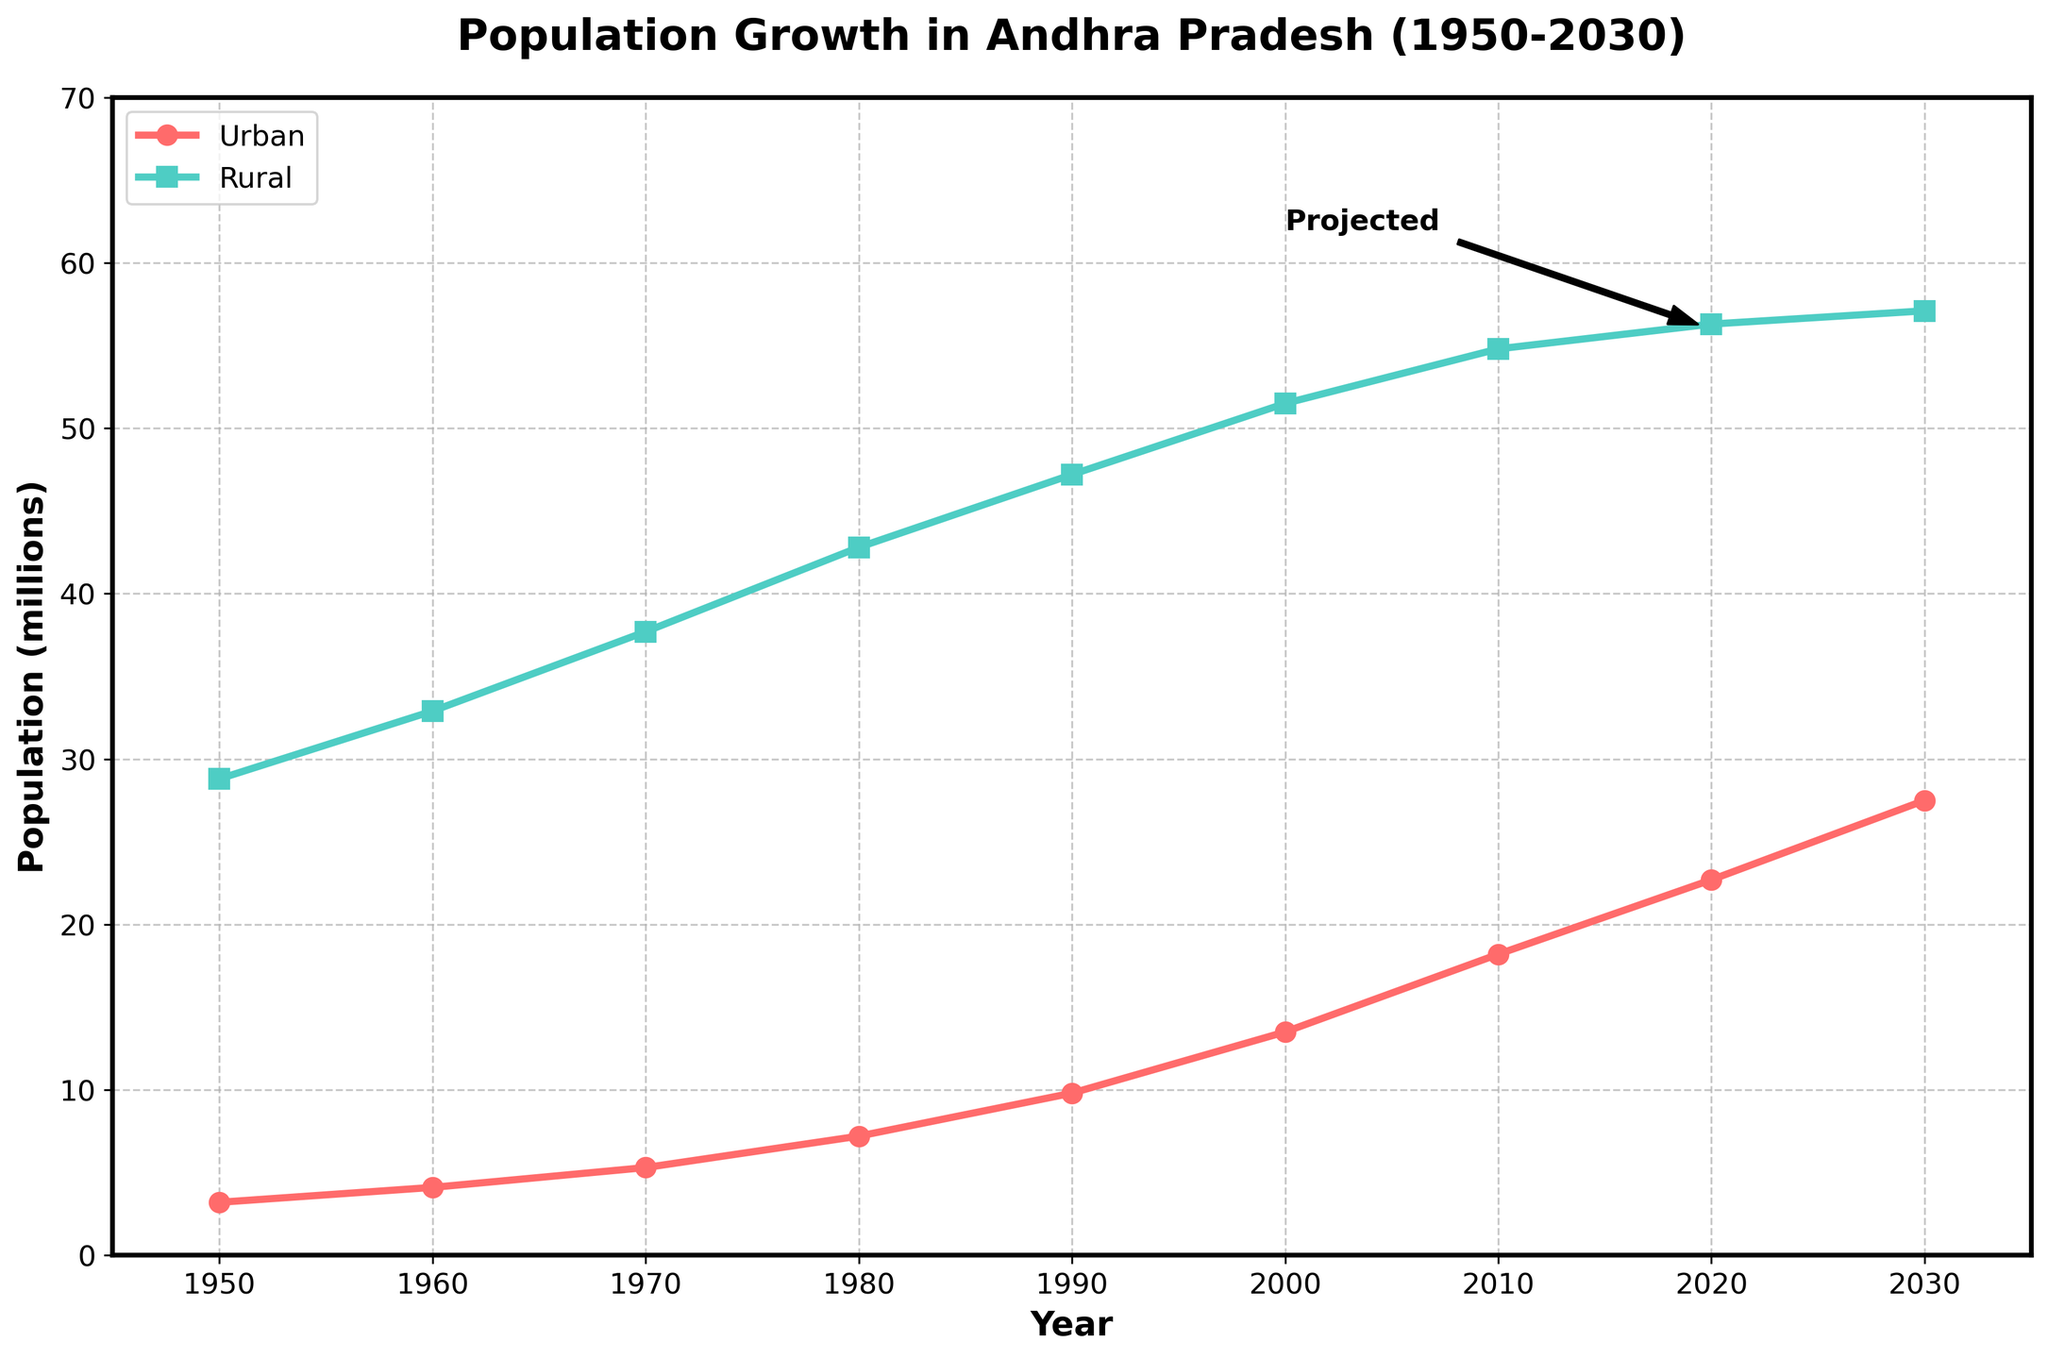What is the trend of the urban population from 1950 to 2020? The urban population shows a consistent upward trend from 3.2 million in 1950 to 22.7 million in 2020.
Answer: Consistent upward trend How does the rural population in 1950 compare to that in 2030? In 1950, the rural population is 28.8 million, whereas in 2030, it is projected to be 57.1 million, showing a significant increase.
Answer: Significant increase Which year between 1950 and 2020 saw the highest growth in urban population? By subtracting the urban population values for consecutive years, the highest increase is from 2000 to 2010, with a rise of 4.7 million (18.2 million-13.5 million).
Answer: 2000 to 2010 What visual feature indicates the area represented by the 'Urban' population? The 'Urban' population is represented by red lines with circular markers. This distinct visual feature helps easily identify the urban population trend.
Answer: Red lines with circular markers By how much did the rural population grow between 1950 and 2020? The rural population in 1950 is 28.8 million, and in 2020, it is 56.3 million. The growth is 56.3 million - 28.8 million = 27.5 million.
Answer: 27.5 million In what year does the urban population first exceed 10 million? Referring to the data, the urban population first exceeds 10 million around 1990.
Answer: 1990 What is the approximate population difference between rural and urban areas in 2020? In 2020, the rural population is 56.3 million, and the urban population is 22.7 million. The difference is 56.3 million - 22.7 million = 33.6 million.
Answer: 33.6 million What annotation is used in the chart to describe the population values post-2020? The chart uses an annotation labeled 'Projected' with an arrow pointing from 2000 to 2020 to 2020's data points.
Answer: Projected Comparing 1970 and 1980, which population (urban or rural) saw a higher absolute increase? Urban population in 1970 is 5.3 million and in 1980 is 7.2 million, an increase of 1.9 million. Rural population in 1970 is 37.7 million and in 1980 is 42.8 million, an increase of 5.1 million. Hence, rural saw a higher increase.
Answer: Rural When does the rural population approximately reach its highest point based on the chart? The rural population reaches its highest point around 2030, as indicated by the plotted data points.
Answer: 2030 